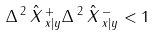<formula> <loc_0><loc_0><loc_500><loc_500>\Delta \, ^ { 2 } \, \hat { X } \, ^ { + } _ { x | y } \Delta \, ^ { 2 } \, \hat { X } \, ^ { - } _ { x | y } < 1</formula> 